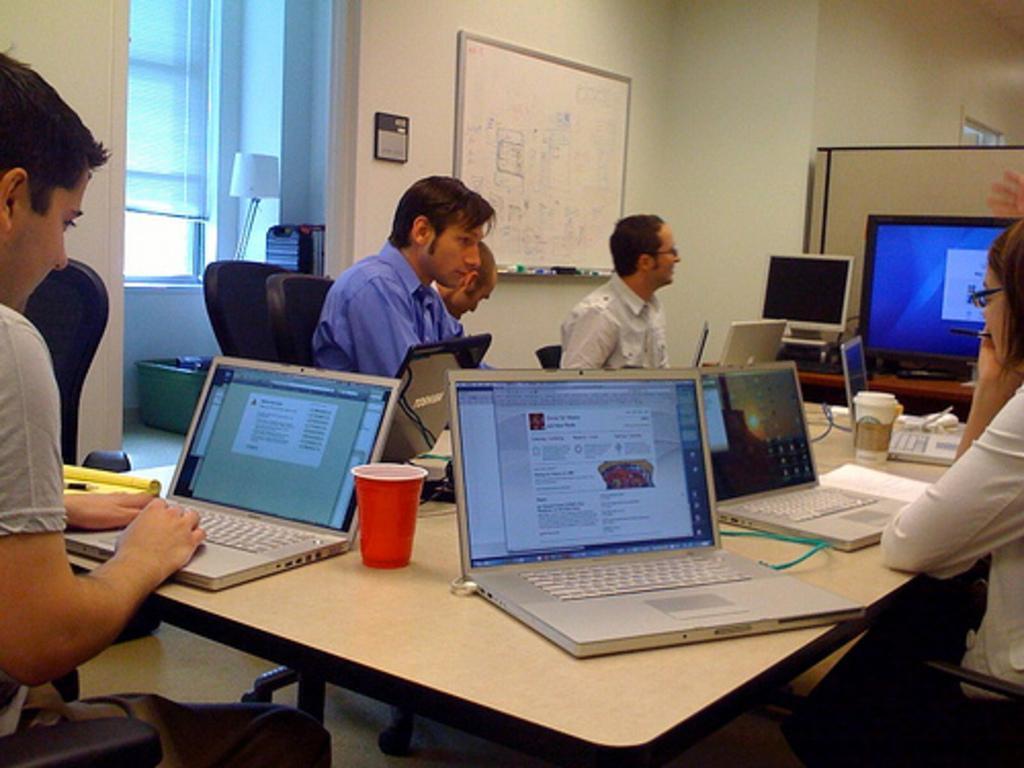Could you give a brief overview of what you see in this image? In this image I can see few men are sitting on chairs. I can also see a table and on this table I can see few laptops and glasses. In the background I can see monitors and a whiteboard on this wall. Here I can see a lamp. 